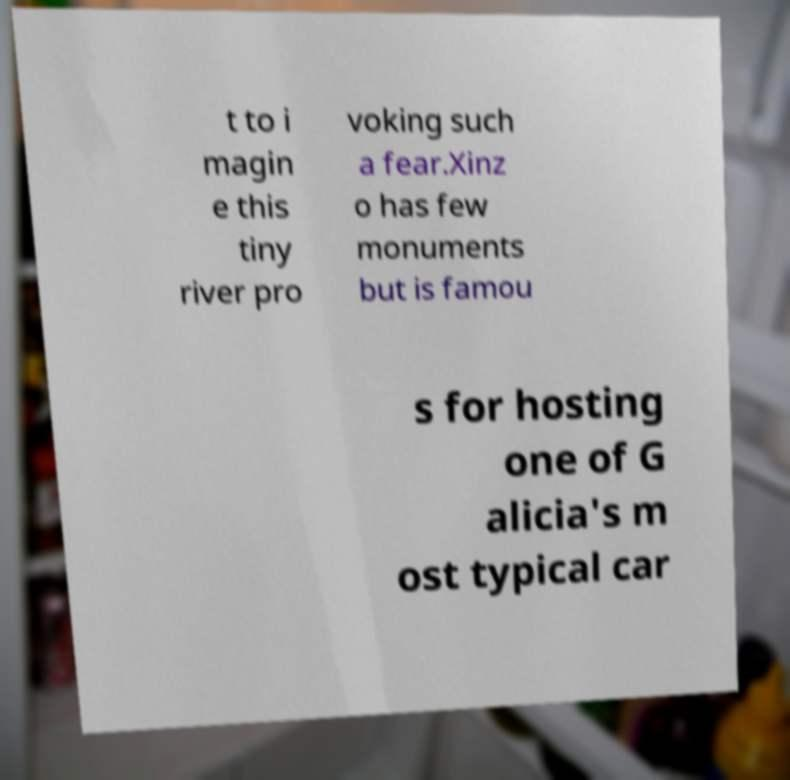Please read and relay the text visible in this image. What does it say? t to i magin e this tiny river pro voking such a fear.Xinz o has few monuments but is famou s for hosting one of G alicia's m ost typical car 